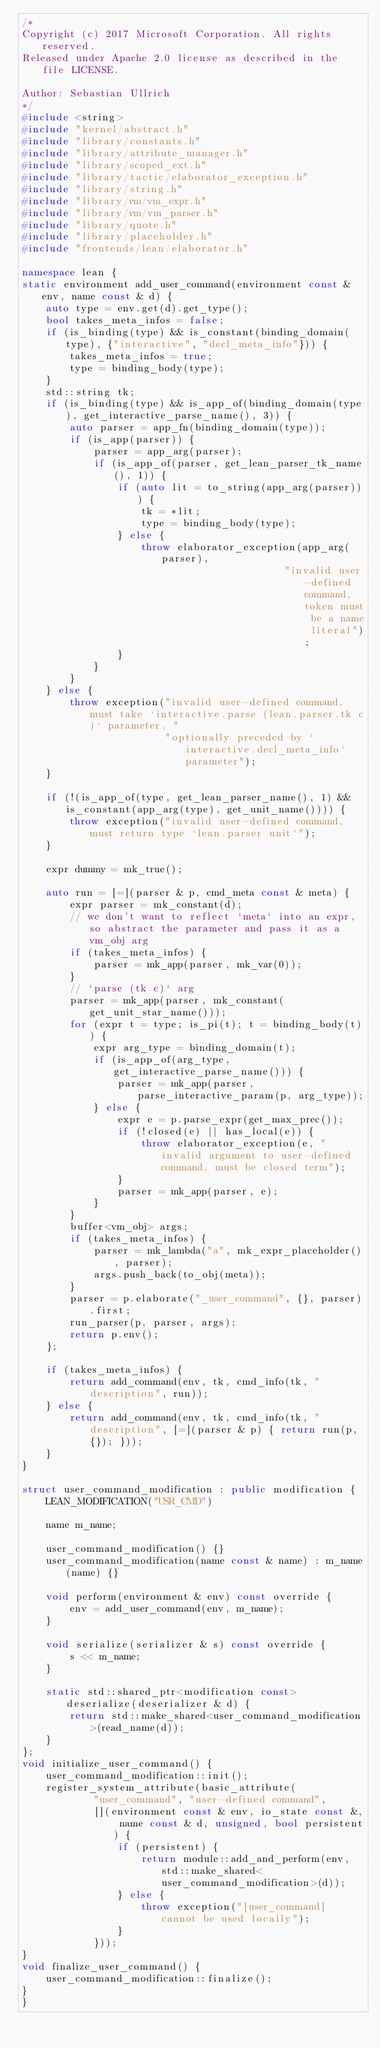<code> <loc_0><loc_0><loc_500><loc_500><_C++_>/*
Copyright (c) 2017 Microsoft Corporation. All rights reserved.
Released under Apache 2.0 license as described in the file LICENSE.

Author: Sebastian Ullrich
*/
#include <string>
#include "kernel/abstract.h"
#include "library/constants.h"
#include "library/attribute_manager.h"
#include "library/scoped_ext.h"
#include "library/tactic/elaborator_exception.h"
#include "library/string.h"
#include "library/vm/vm_expr.h"
#include "library/vm/vm_parser.h"
#include "library/quote.h"
#include "library/placeholder.h"
#include "frontends/lean/elaborator.h"

namespace lean {
static environment add_user_command(environment const & env, name const & d) {
    auto type = env.get(d).get_type();
    bool takes_meta_infos = false;
    if (is_binding(type) && is_constant(binding_domain(type), {"interactive", "decl_meta_info"})) {
        takes_meta_infos = true;
        type = binding_body(type);
    }
    std::string tk;
    if (is_binding(type) && is_app_of(binding_domain(type), get_interactive_parse_name(), 3)) {
        auto parser = app_fn(binding_domain(type));
        if (is_app(parser)) {
            parser = app_arg(parser);
            if (is_app_of(parser, get_lean_parser_tk_name(), 1)) {
                if (auto lit = to_string(app_arg(parser))) {
                    tk = *lit;
                    type = binding_body(type);
                } else {
                    throw elaborator_exception(app_arg(parser),
                                            "invalid user-defined command, token must be a name literal");
                }
            }
        }
    } else {
        throw exception("invalid user-defined command, must take `interactive.parse (lean.parser.tk c)` parameter, "
                        "optionally preceded by `interactive.decl_meta_info` parameter");
    }

    if (!(is_app_of(type, get_lean_parser_name(), 1) && is_constant(app_arg(type), get_unit_name()))) {
        throw exception("invalid user-defined command, must return type `lean.parser unit`");
    }

    expr dummy = mk_true();

    auto run = [=](parser & p, cmd_meta const & meta) {
        expr parser = mk_constant(d);
        // we don't want to reflect `meta` into an expr, so abstract the parameter and pass it as a vm_obj arg
        if (takes_meta_infos) {
            parser = mk_app(parser, mk_var(0));
        }
        // `parse (tk c)` arg
        parser = mk_app(parser, mk_constant(get_unit_star_name()));
        for (expr t = type; is_pi(t); t = binding_body(t)) {
            expr arg_type = binding_domain(t);
            if (is_app_of(arg_type, get_interactive_parse_name())) {
                parser = mk_app(parser, parse_interactive_param(p, arg_type));
            } else {
                expr e = p.parse_expr(get_max_prec());
                if (!closed(e) || has_local(e)) {
                    throw elaborator_exception(e, "invalid argument to user-defined command, must be closed term");
                }
                parser = mk_app(parser, e);
            }
        }
        buffer<vm_obj> args;
        if (takes_meta_infos) {
            parser = mk_lambda("a", mk_expr_placeholder(), parser);
            args.push_back(to_obj(meta));
        }
        parser = p.elaborate("_user_command", {}, parser).first;
        run_parser(p, parser, args);
        return p.env();
    };

    if (takes_meta_infos) {
        return add_command(env, tk, cmd_info(tk, "description", run));
    } else {
        return add_command(env, tk, cmd_info(tk, "description", [=](parser & p) { return run(p, {}); }));
    }
}

struct user_command_modification : public modification {
    LEAN_MODIFICATION("USR_CMD")

    name m_name;

    user_command_modification() {}
    user_command_modification(name const & name) : m_name(name) {}

    void perform(environment & env) const override {
        env = add_user_command(env, m_name);
    }

    void serialize(serializer & s) const override {
        s << m_name;
    }

    static std::shared_ptr<modification const> deserialize(deserializer & d) {
        return std::make_shared<user_command_modification>(read_name(d));
    }
};
void initialize_user_command() {
    user_command_modification::init();
    register_system_attribute(basic_attribute(
            "user_command", "user-defined command",
            [](environment const & env, io_state const &, name const & d, unsigned, bool persistent) {
                if (persistent) {
                    return module::add_and_perform(env, std::make_shared<user_command_modification>(d));
                } else {
                    throw exception("[user_command] cannot be used locally");
                }
            }));
}
void finalize_user_command() {
    user_command_modification::finalize();
}
}
</code> 